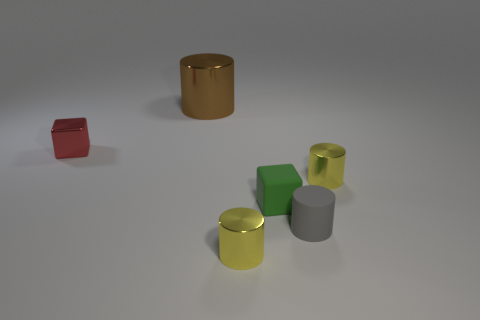Add 3 tiny gray things. How many objects exist? 9 Subtract all cylinders. How many objects are left? 2 Subtract all small red rubber spheres. Subtract all green objects. How many objects are left? 5 Add 4 big brown metallic objects. How many big brown metallic objects are left? 5 Add 2 tiny green objects. How many tiny green objects exist? 3 Subtract 0 yellow blocks. How many objects are left? 6 